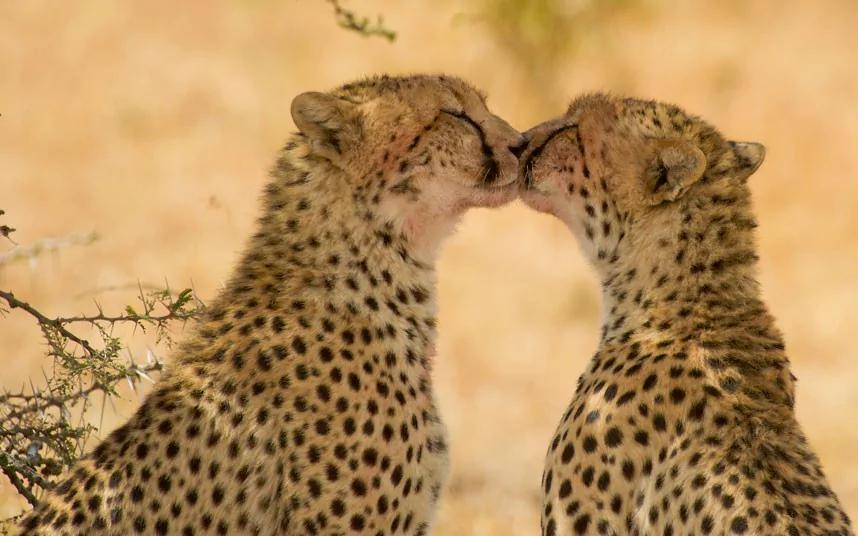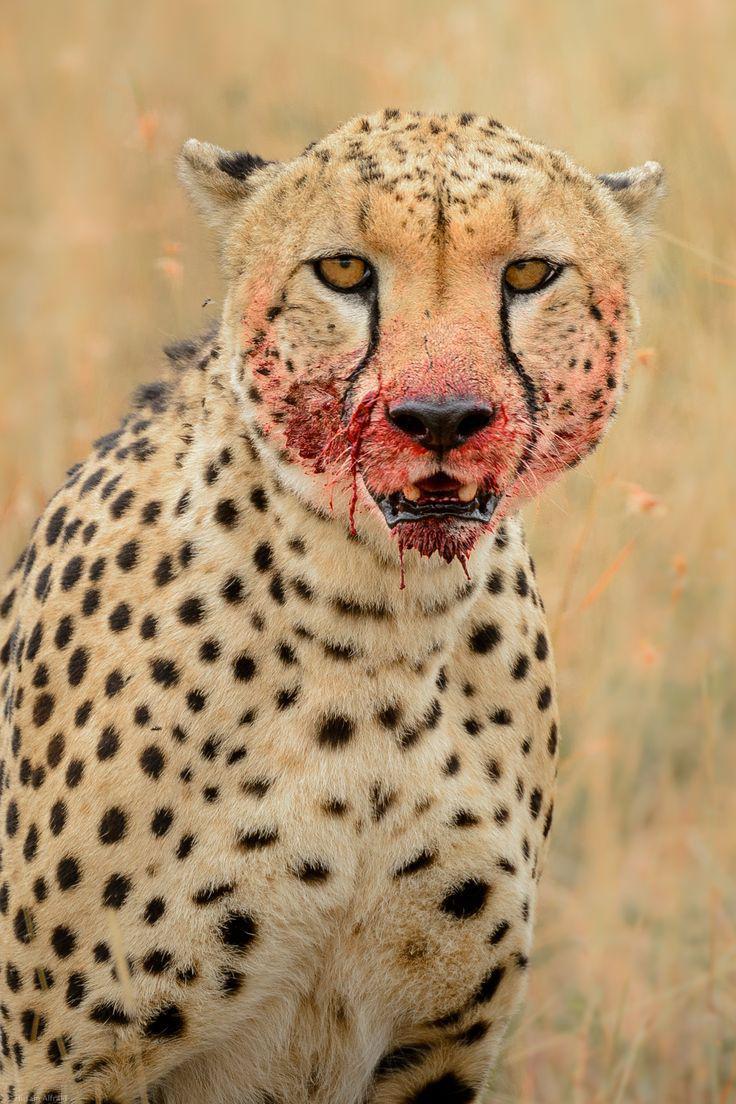The first image is the image on the left, the second image is the image on the right. Assess this claim about the two images: "An image shows two same-sized similarly-posed spotted cats with their heads close together.". Correct or not? Answer yes or no. Yes. The first image is the image on the left, the second image is the image on the right. For the images displayed, is the sentence "The left image contains at least two cheetahs." factually correct? Answer yes or no. Yes. 